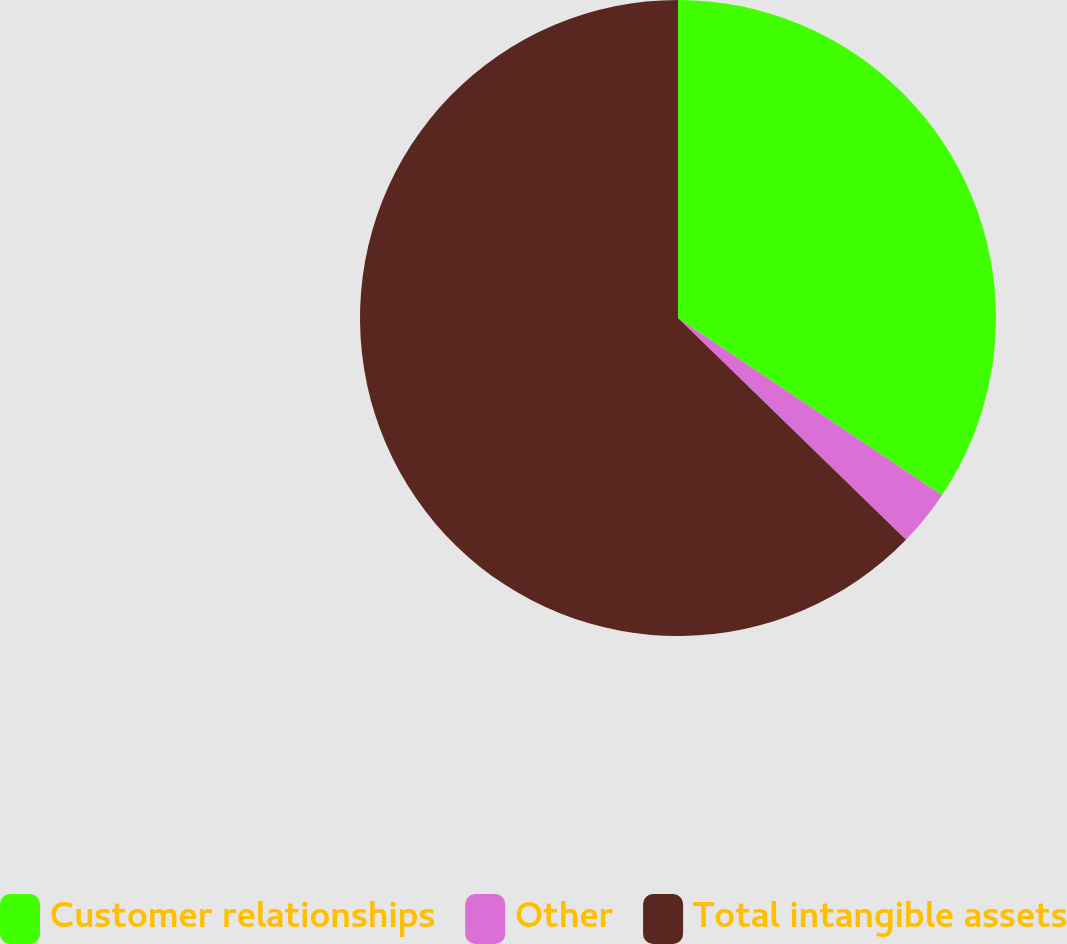Convert chart. <chart><loc_0><loc_0><loc_500><loc_500><pie_chart><fcel>Customer relationships<fcel>Other<fcel>Total intangible assets<nl><fcel>34.41%<fcel>2.87%<fcel>62.73%<nl></chart> 